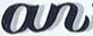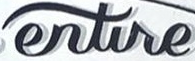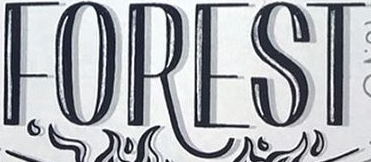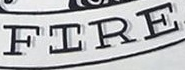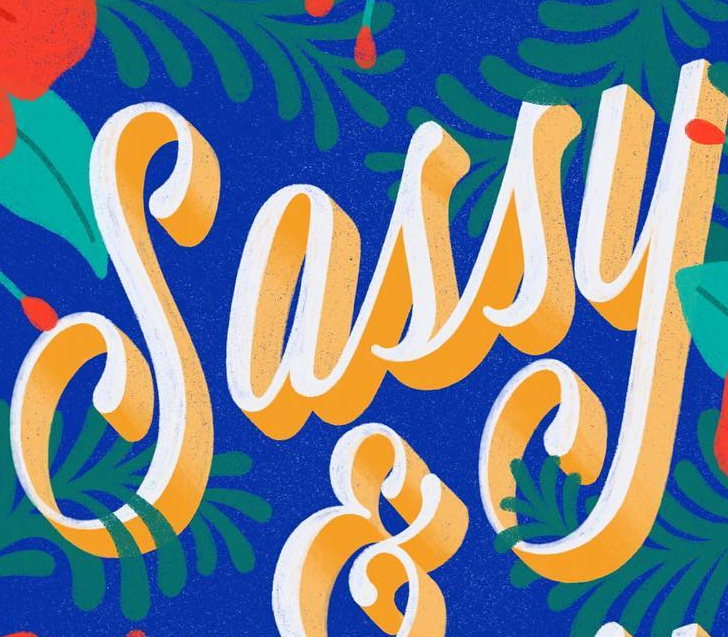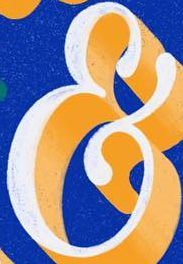What text is displayed in these images sequentially, separated by a semicolon? an; entire; FOREST; FIRE; Sassy; & 